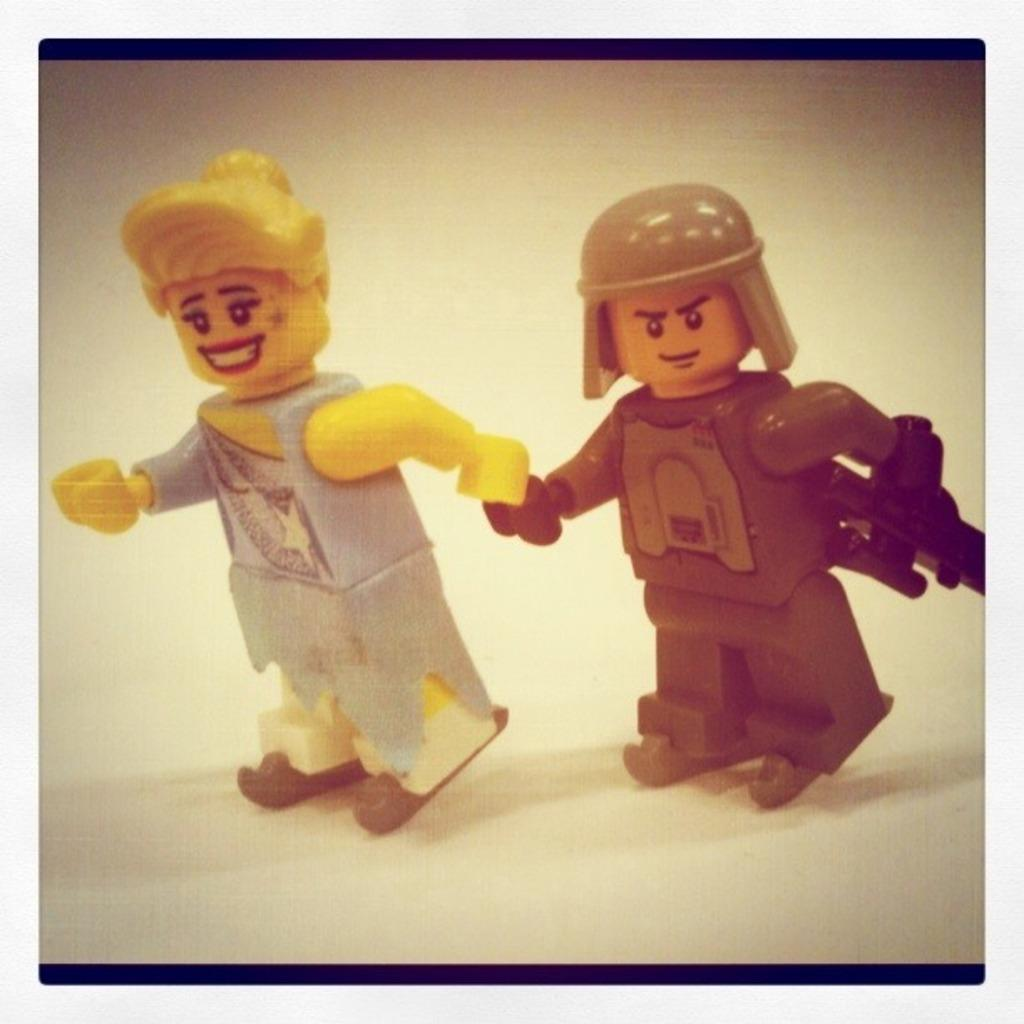How many toys are visible in the image? There are two toys in the image. Where are the toys located? The toys are on a platform. Can you describe the expression of one of the toys? One of the toys is smiling. Where is the sheep located in the image? There is no sheep present in the image. 